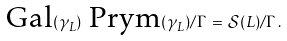<formula> <loc_0><loc_0><loc_500><loc_500>\text {Gal} ( \gamma _ { L } ) \ \text {Prym} ( \gamma _ { L } ) / \Gamma \, = \, { \mathcal { S } } ( L ) / \Gamma \, .</formula> 